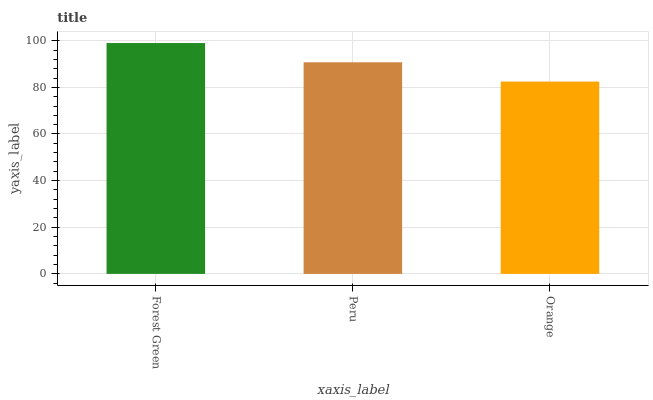Is Orange the minimum?
Answer yes or no. Yes. Is Forest Green the maximum?
Answer yes or no. Yes. Is Peru the minimum?
Answer yes or no. No. Is Peru the maximum?
Answer yes or no. No. Is Forest Green greater than Peru?
Answer yes or no. Yes. Is Peru less than Forest Green?
Answer yes or no. Yes. Is Peru greater than Forest Green?
Answer yes or no. No. Is Forest Green less than Peru?
Answer yes or no. No. Is Peru the high median?
Answer yes or no. Yes. Is Peru the low median?
Answer yes or no. Yes. Is Orange the high median?
Answer yes or no. No. Is Orange the low median?
Answer yes or no. No. 